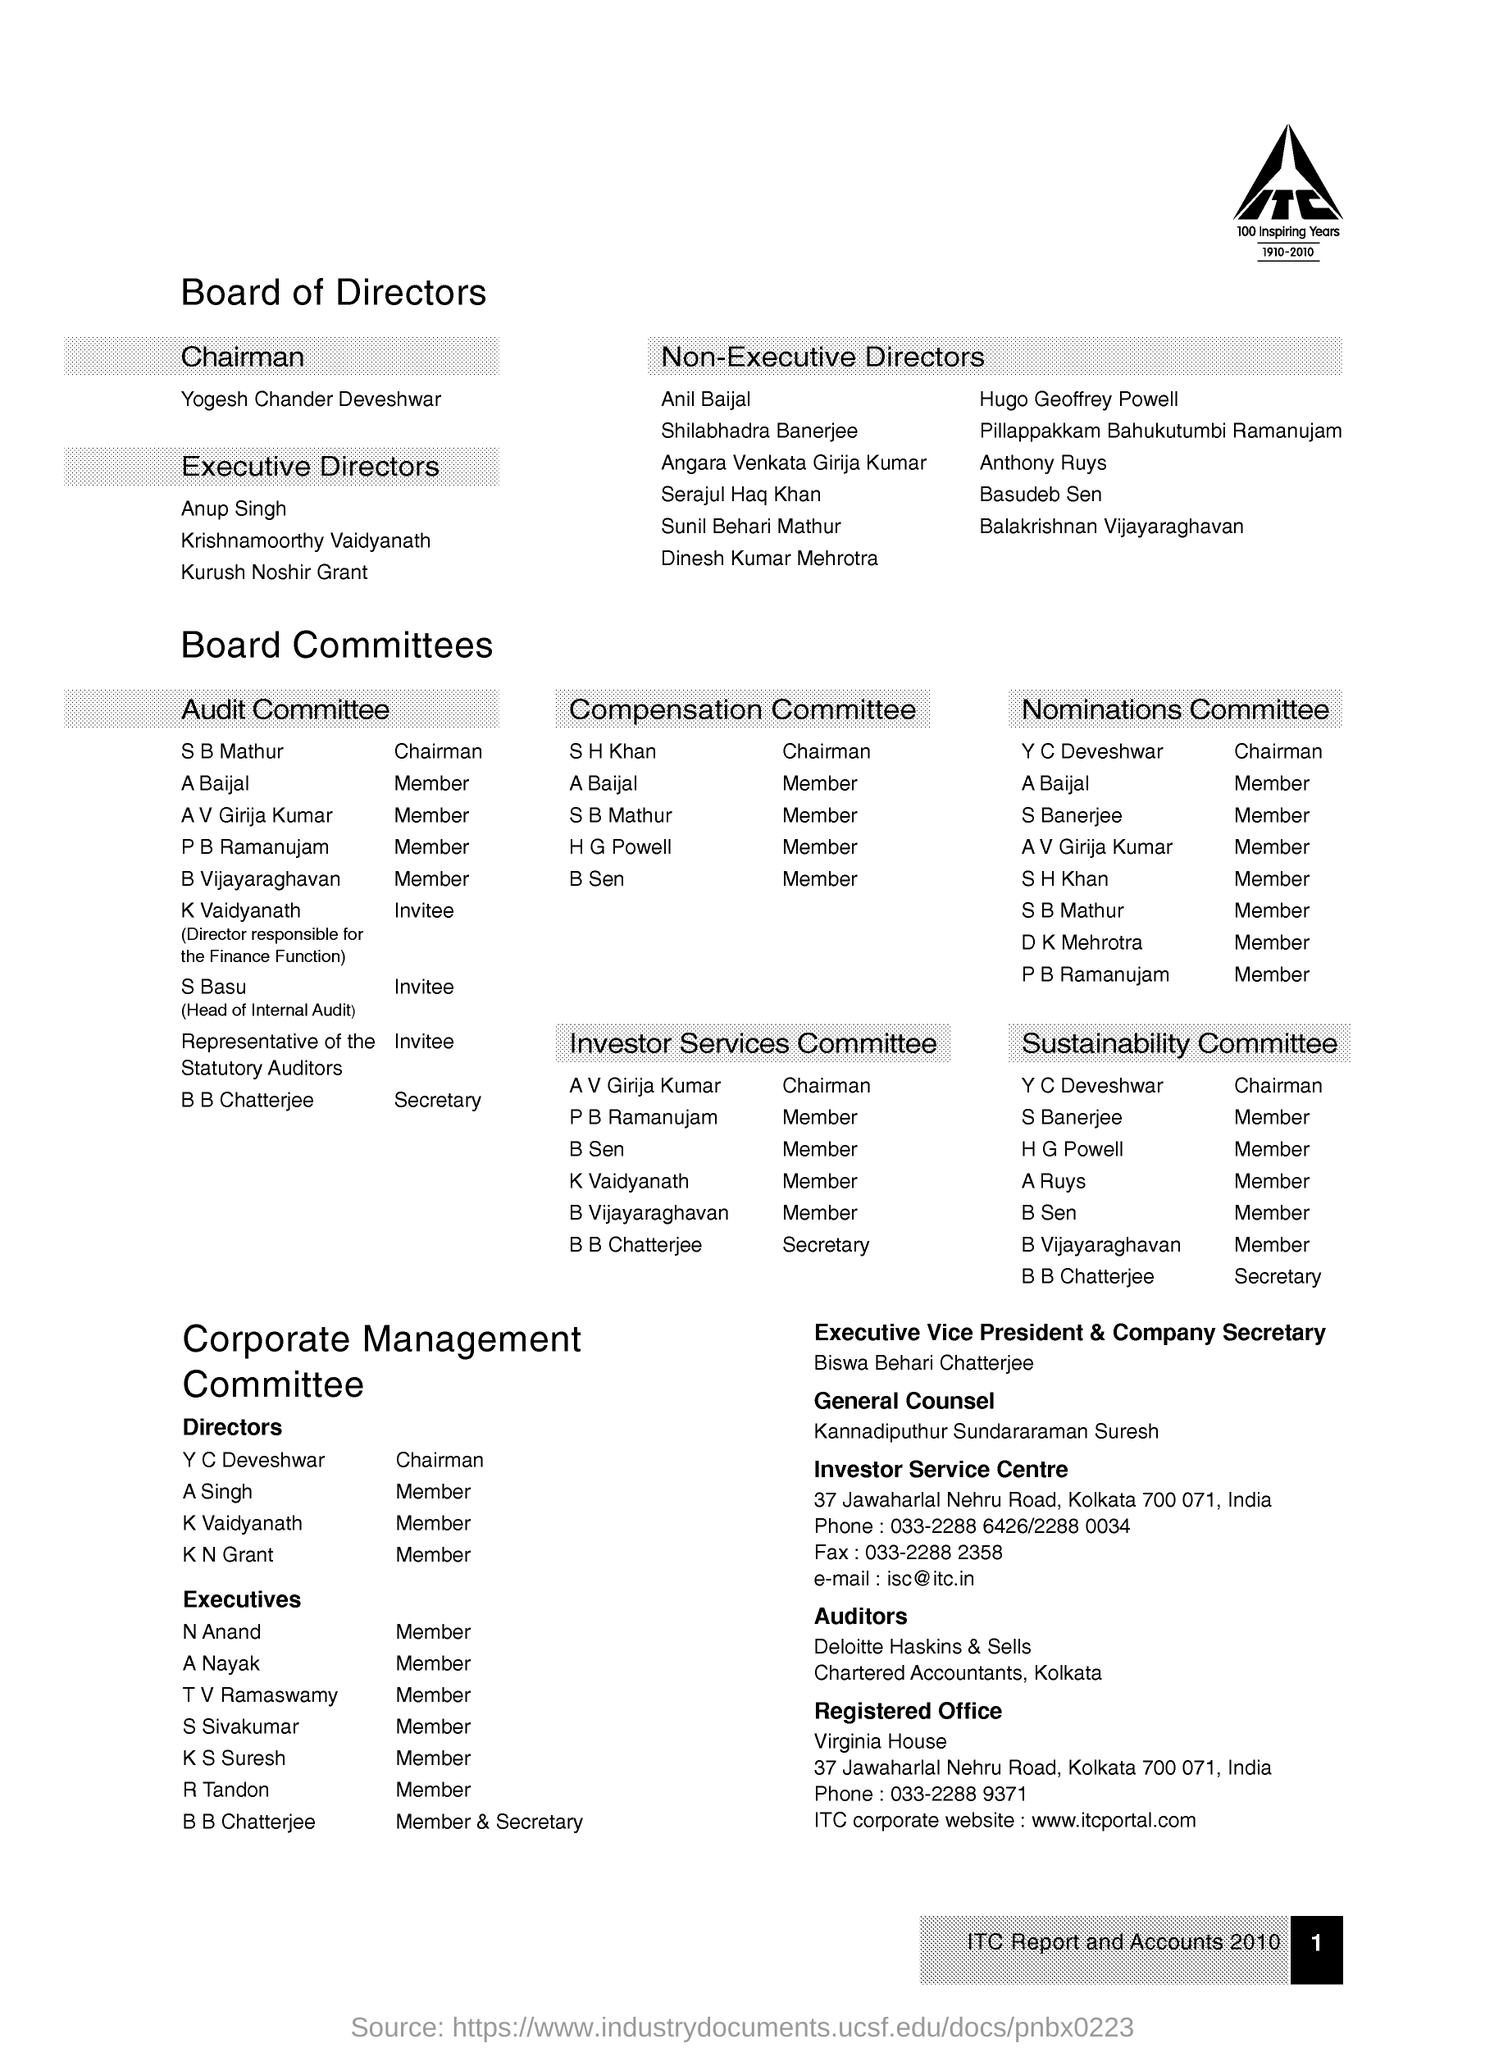In which city registered office is located ?
Your response must be concise. Kolkata. Who is the chairman of the company ?
Keep it short and to the point. Yogesh Chander Deveshwar. Who is the executive vice president & company secretary ?
Your response must be concise. Biswa behari chatterjee. Who is the general counsel ?
Your response must be concise. Kannadiputhur sundararaman suresh. What is the e-mail of investor service centre
Your answer should be very brief. Isc@itc.in. 